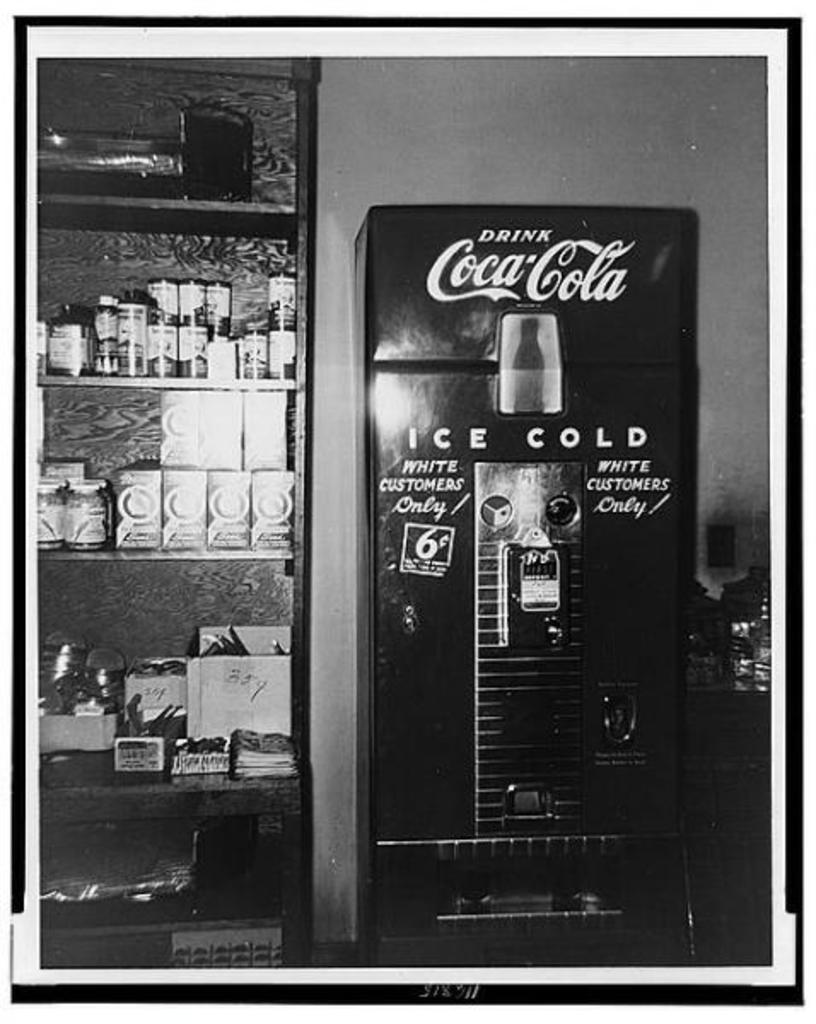What brand of drink is in the machine?
Offer a terse response. Coca cola. What brand of soda is this?
Your answer should be very brief. Coca cola. 